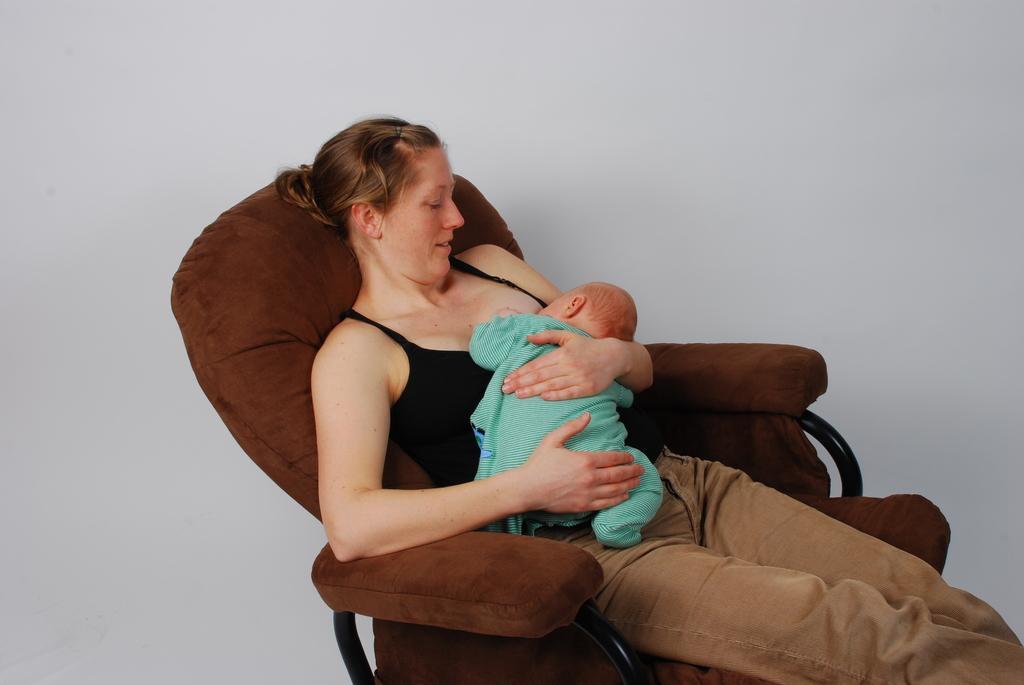Describe this image in one or two sentences. In this picture we can see a woman is holding a baby and sitting on a chair. Behind the chair there is a white background. 